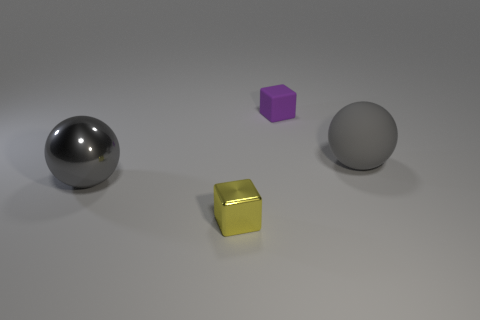Add 3 gray rubber objects. How many objects exist? 7 Subtract 1 yellow blocks. How many objects are left? 3 Subtract all small brown things. Subtract all large gray metallic things. How many objects are left? 3 Add 4 large gray rubber balls. How many large gray rubber balls are left? 5 Add 1 metal things. How many metal things exist? 3 